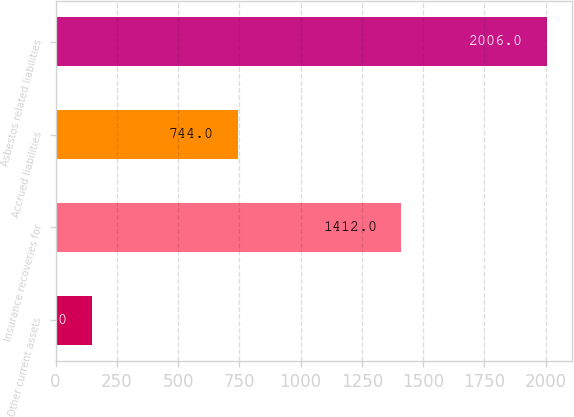Convert chart. <chart><loc_0><loc_0><loc_500><loc_500><bar_chart><fcel>Other current assets<fcel>Insurance recoveries for<fcel>Accrued liabilities<fcel>Asbestos related liabilities<nl><fcel>150<fcel>1412<fcel>744<fcel>2006<nl></chart> 